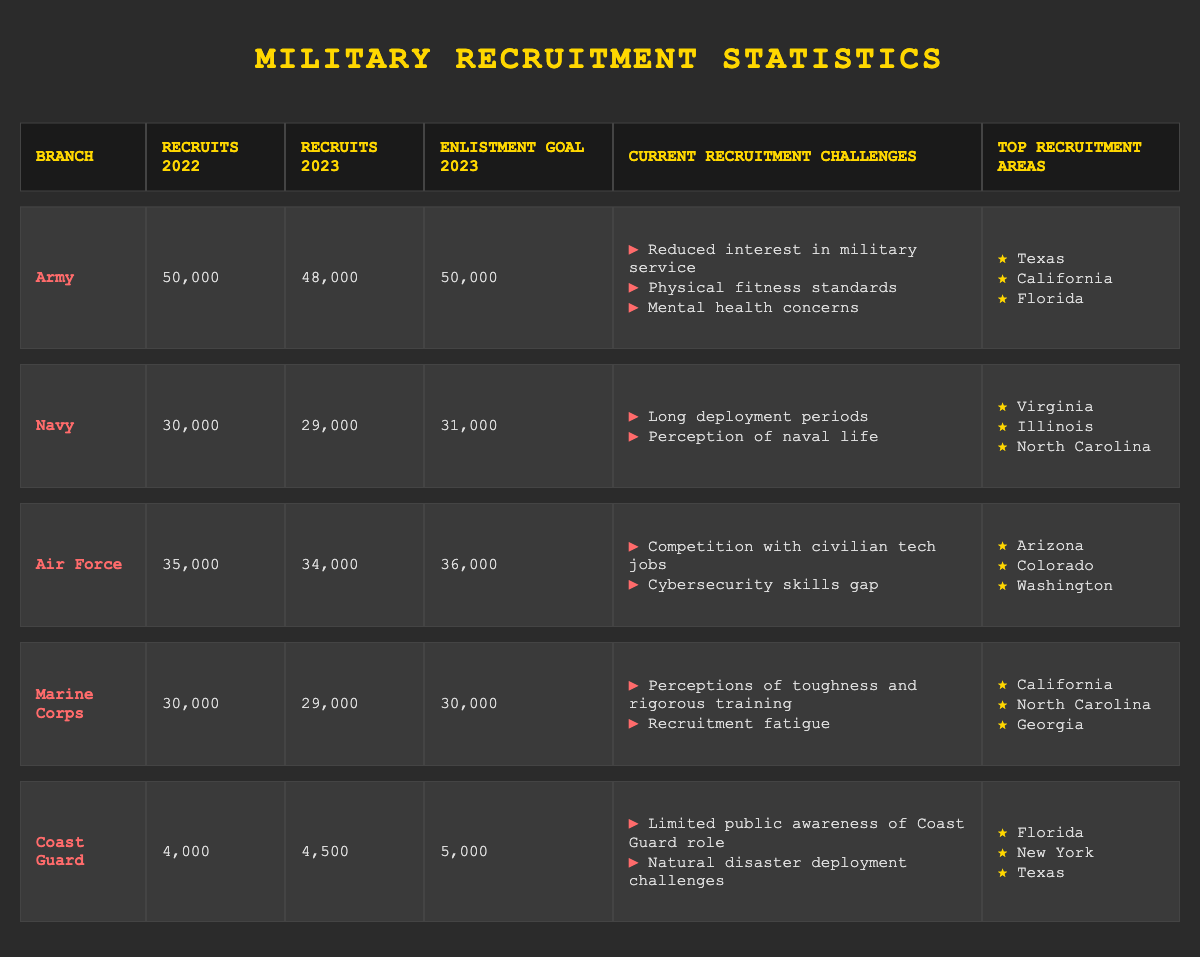What was the recruitment goal for the Navy in 2023? The table shows that the enlistment goal for the Navy in 2023 is explicitly listed as 31,000.
Answer: 31,000 Which branch had the highest number of recruits in 2022? By comparing the "Recruits 2022" column, the Army had the highest number with 50,000 recruits.
Answer: Army Did the Air Force meet its recruitment goal for 2023? The Air Force had a recruitment goal of 36,000 but had only 34,000 recruits in 2023, indicating it did not meet the goal.
Answer: No What is the total number of recruits for the Army and Marine Corps in 2023? Adding up the recruits for the Army (48,000) and Marine Corps (29,000) gives a total of 77,000 recruits in 2023.
Answer: 77,000 Which branch faced recruitment challenges related to perceptions of lifestyle? The Navy has recruitment challenges associated with long deployment periods and the perception of naval life, indicating these are linked to lifestyle perceptions.
Answer: Navy What is the average number of recruits across all branches for 2022? Adding together the recruits from all branches for 2022 gives 195,000 (50,000 + 30,000 + 35,000 + 30,000 + 4,000). Dividing by 5 branches gives an average of 39,000.
Answer: 39,000 Which branch had the least number of recruits in 2023? The Coast Guard had the least number of recruits in 2023 with 4,500, as compared to all other branches.
Answer: Coast Guard How many more recruits did the Air Force have compared to the Navy in 2023? The difference in recruits between the Air Force (34,000) and Navy (29,000) is 5,000, calculated as 34,000 - 29,000.
Answer: 5,000 Among the top recruitment areas, which are shared by the Army and Coast Guard? The top recruitment area for both the Army and Coast Guard is Texas, as indicated in their respective lists in the table.
Answer: Texas What was the change in recruitment numbers for the Marine Corps from 2022 to 2023? The Marine Corps had 30,000 recruits in 2022 and 29,000 in 2023, representing a decrease of 1,000 recruits which is calculated as 30,000 - 29,000.
Answer: 1,000 decrease Is recruitment fatigue a challenge for the Army? The table does not list recruitment fatigue as a challenge for the Army. Instead, it focuses on reduced interest, physical fitness standards, and mental health concerns.
Answer: No 